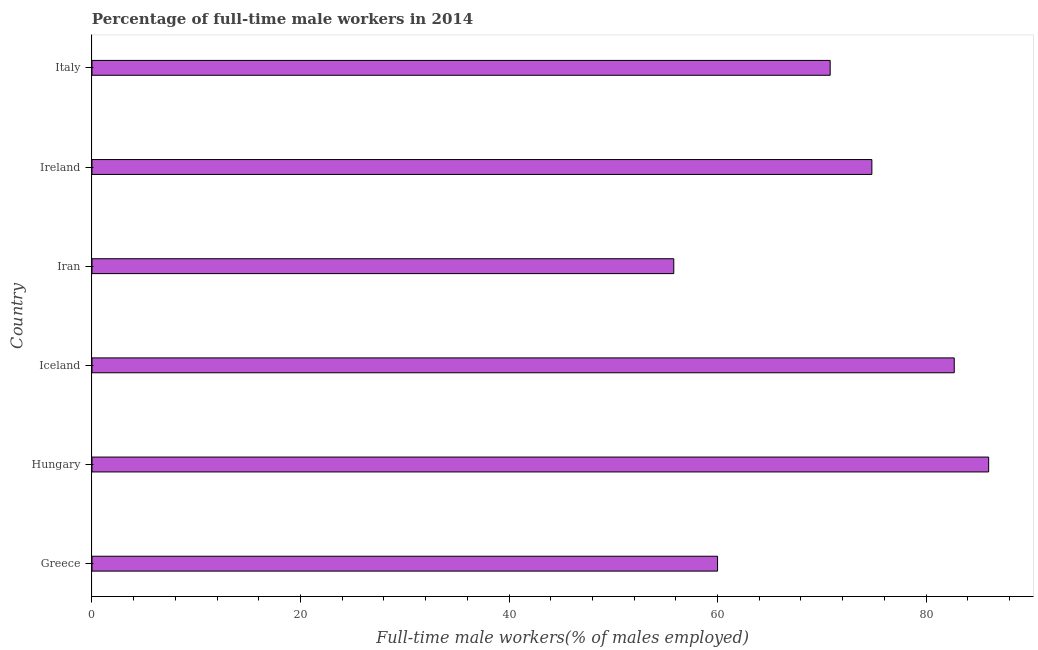Does the graph contain any zero values?
Offer a terse response. No. Does the graph contain grids?
Provide a succinct answer. No. What is the title of the graph?
Provide a short and direct response. Percentage of full-time male workers in 2014. What is the label or title of the X-axis?
Your answer should be very brief. Full-time male workers(% of males employed). What is the percentage of full-time male workers in Greece?
Offer a very short reply. 60. Across all countries, what is the minimum percentage of full-time male workers?
Provide a succinct answer. 55.8. In which country was the percentage of full-time male workers maximum?
Make the answer very short. Hungary. In which country was the percentage of full-time male workers minimum?
Your answer should be very brief. Iran. What is the sum of the percentage of full-time male workers?
Your answer should be compact. 430.1. What is the difference between the percentage of full-time male workers in Iran and Italy?
Your answer should be compact. -15. What is the average percentage of full-time male workers per country?
Keep it short and to the point. 71.68. What is the median percentage of full-time male workers?
Offer a terse response. 72.8. In how many countries, is the percentage of full-time male workers greater than 40 %?
Provide a succinct answer. 6. What is the ratio of the percentage of full-time male workers in Hungary to that in Ireland?
Provide a short and direct response. 1.15. What is the difference between the highest and the second highest percentage of full-time male workers?
Provide a succinct answer. 3.3. What is the difference between the highest and the lowest percentage of full-time male workers?
Give a very brief answer. 30.2. How many bars are there?
Ensure brevity in your answer.  6. What is the difference between two consecutive major ticks on the X-axis?
Offer a terse response. 20. Are the values on the major ticks of X-axis written in scientific E-notation?
Your answer should be compact. No. What is the Full-time male workers(% of males employed) in Greece?
Your answer should be compact. 60. What is the Full-time male workers(% of males employed) in Hungary?
Your answer should be very brief. 86. What is the Full-time male workers(% of males employed) in Iceland?
Your answer should be compact. 82.7. What is the Full-time male workers(% of males employed) of Iran?
Keep it short and to the point. 55.8. What is the Full-time male workers(% of males employed) in Ireland?
Make the answer very short. 74.8. What is the Full-time male workers(% of males employed) of Italy?
Offer a very short reply. 70.8. What is the difference between the Full-time male workers(% of males employed) in Greece and Hungary?
Offer a terse response. -26. What is the difference between the Full-time male workers(% of males employed) in Greece and Iceland?
Ensure brevity in your answer.  -22.7. What is the difference between the Full-time male workers(% of males employed) in Greece and Ireland?
Make the answer very short. -14.8. What is the difference between the Full-time male workers(% of males employed) in Greece and Italy?
Offer a very short reply. -10.8. What is the difference between the Full-time male workers(% of males employed) in Hungary and Iceland?
Ensure brevity in your answer.  3.3. What is the difference between the Full-time male workers(% of males employed) in Hungary and Iran?
Your answer should be very brief. 30.2. What is the difference between the Full-time male workers(% of males employed) in Hungary and Ireland?
Offer a terse response. 11.2. What is the difference between the Full-time male workers(% of males employed) in Hungary and Italy?
Keep it short and to the point. 15.2. What is the difference between the Full-time male workers(% of males employed) in Iceland and Iran?
Keep it short and to the point. 26.9. What is the difference between the Full-time male workers(% of males employed) in Iceland and Ireland?
Offer a very short reply. 7.9. What is the difference between the Full-time male workers(% of males employed) in Iceland and Italy?
Keep it short and to the point. 11.9. What is the difference between the Full-time male workers(% of males employed) in Iran and Ireland?
Your answer should be compact. -19. What is the ratio of the Full-time male workers(% of males employed) in Greece to that in Hungary?
Make the answer very short. 0.7. What is the ratio of the Full-time male workers(% of males employed) in Greece to that in Iceland?
Offer a very short reply. 0.73. What is the ratio of the Full-time male workers(% of males employed) in Greece to that in Iran?
Keep it short and to the point. 1.07. What is the ratio of the Full-time male workers(% of males employed) in Greece to that in Ireland?
Ensure brevity in your answer.  0.8. What is the ratio of the Full-time male workers(% of males employed) in Greece to that in Italy?
Offer a terse response. 0.85. What is the ratio of the Full-time male workers(% of males employed) in Hungary to that in Iran?
Provide a short and direct response. 1.54. What is the ratio of the Full-time male workers(% of males employed) in Hungary to that in Ireland?
Offer a very short reply. 1.15. What is the ratio of the Full-time male workers(% of males employed) in Hungary to that in Italy?
Make the answer very short. 1.22. What is the ratio of the Full-time male workers(% of males employed) in Iceland to that in Iran?
Keep it short and to the point. 1.48. What is the ratio of the Full-time male workers(% of males employed) in Iceland to that in Ireland?
Offer a very short reply. 1.11. What is the ratio of the Full-time male workers(% of males employed) in Iceland to that in Italy?
Make the answer very short. 1.17. What is the ratio of the Full-time male workers(% of males employed) in Iran to that in Ireland?
Your answer should be compact. 0.75. What is the ratio of the Full-time male workers(% of males employed) in Iran to that in Italy?
Provide a short and direct response. 0.79. What is the ratio of the Full-time male workers(% of males employed) in Ireland to that in Italy?
Provide a short and direct response. 1.06. 